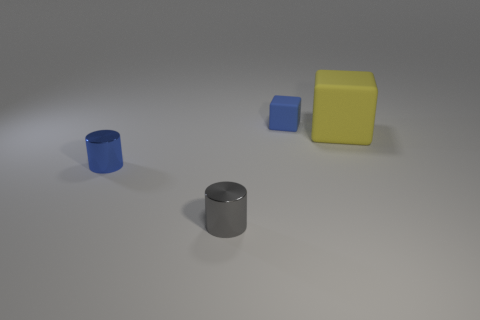What number of other objects are the same color as the small matte object?
Make the answer very short. 1. There is a small object that is behind the cube in front of the rubber thing behind the yellow thing; what is it made of?
Make the answer very short. Rubber. Are there fewer yellow rubber things that are behind the big yellow cube than tiny shiny cylinders?
Your answer should be very brief. Yes. There is a cube that is the same size as the gray object; what is it made of?
Your answer should be compact. Rubber. There is a thing that is right of the small gray cylinder and in front of the tiny block; how big is it?
Your answer should be compact. Large. What is the size of the blue shiny thing that is the same shape as the small gray metallic thing?
Offer a very short reply. Small. How many things are either large gray objects or matte blocks on the left side of the big yellow rubber block?
Give a very brief answer. 1. The tiny rubber object is what shape?
Make the answer very short. Cube. The metal thing to the right of the tiny blue thing in front of the blue matte cube is what shape?
Provide a succinct answer. Cylinder. There is a small cylinder that is the same color as the tiny matte block; what is it made of?
Ensure brevity in your answer.  Metal. 